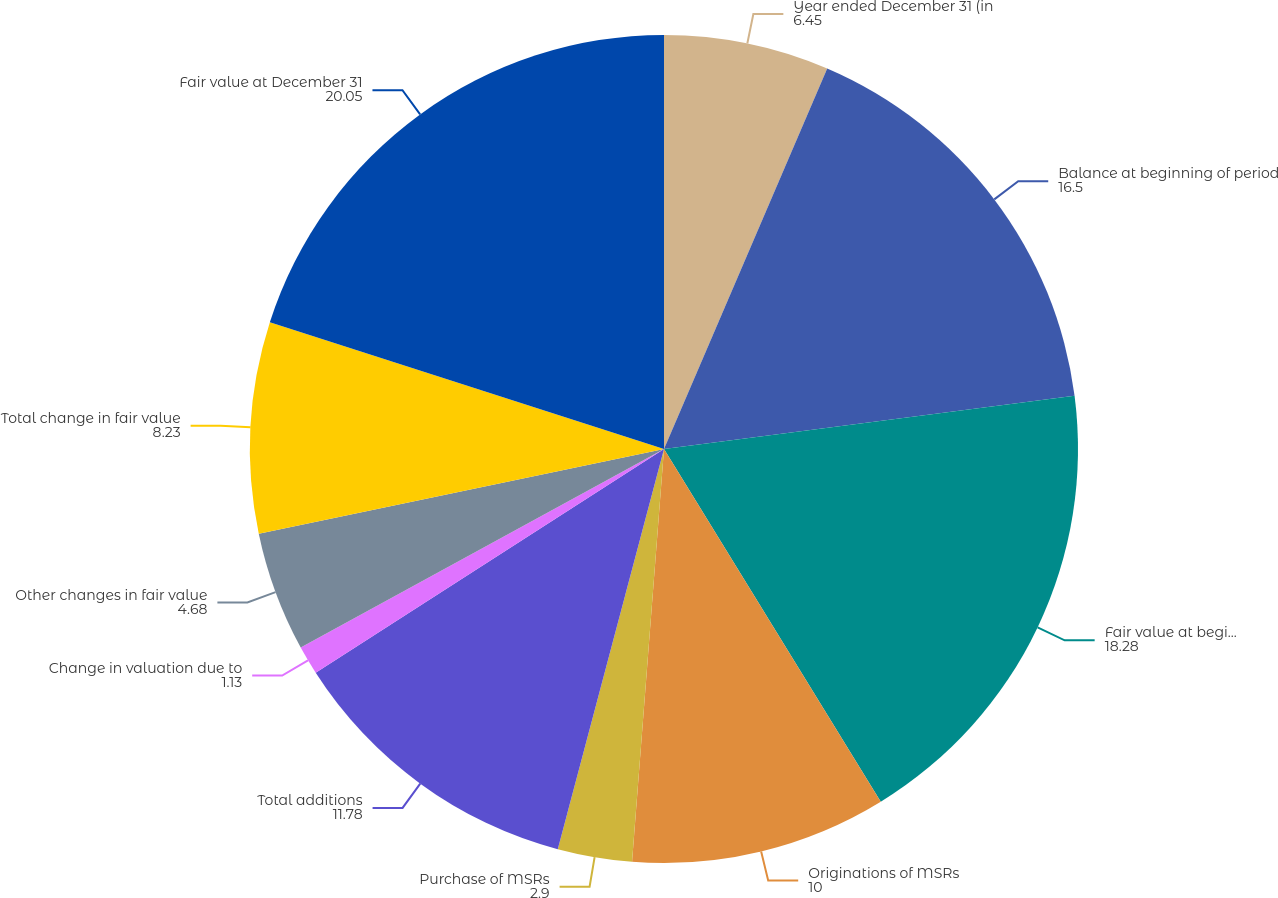Convert chart to OTSL. <chart><loc_0><loc_0><loc_500><loc_500><pie_chart><fcel>Year ended December 31 (in<fcel>Balance at beginning of period<fcel>Fair value at beginning of<fcel>Originations of MSRs<fcel>Purchase of MSRs<fcel>Total additions<fcel>Change in valuation due to<fcel>Other changes in fair value<fcel>Total change in fair value<fcel>Fair value at December 31<nl><fcel>6.45%<fcel>16.5%<fcel>18.28%<fcel>10.0%<fcel>2.9%<fcel>11.78%<fcel>1.13%<fcel>4.68%<fcel>8.23%<fcel>20.05%<nl></chart> 